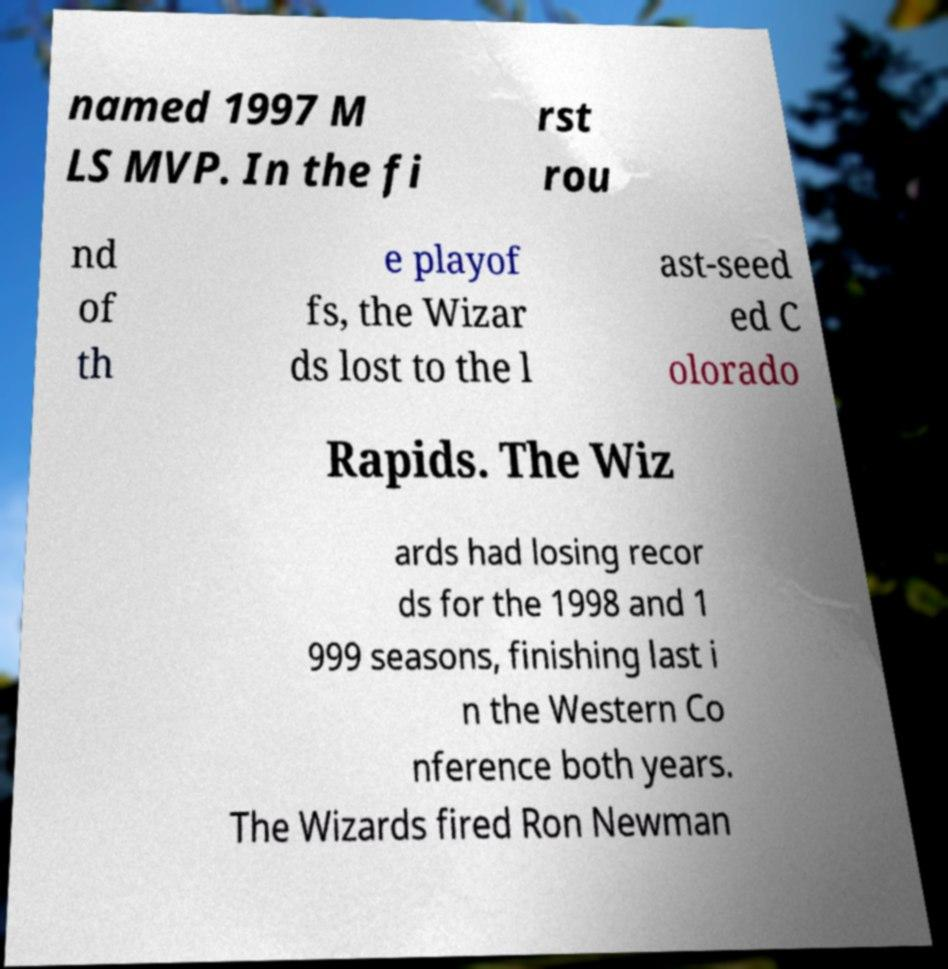Could you assist in decoding the text presented in this image and type it out clearly? named 1997 M LS MVP. In the fi rst rou nd of th e playof fs, the Wizar ds lost to the l ast-seed ed C olorado Rapids. The Wiz ards had losing recor ds for the 1998 and 1 999 seasons, finishing last i n the Western Co nference both years. The Wizards fired Ron Newman 